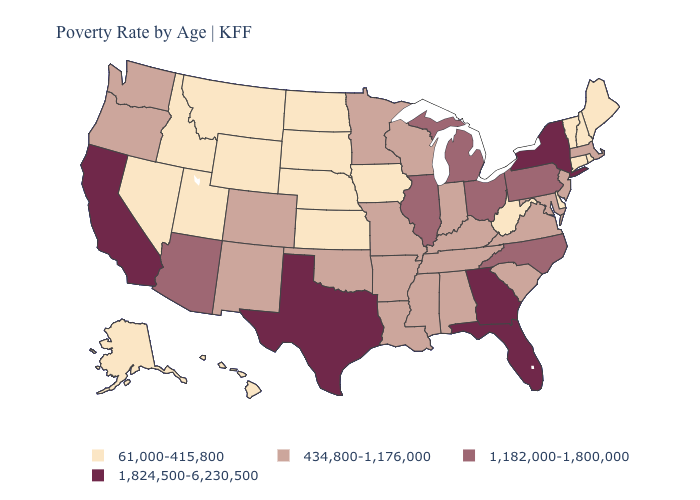How many symbols are there in the legend?
Answer briefly. 4. Which states have the lowest value in the USA?
Give a very brief answer. Alaska, Connecticut, Delaware, Hawaii, Idaho, Iowa, Kansas, Maine, Montana, Nebraska, Nevada, New Hampshire, North Dakota, Rhode Island, South Dakota, Utah, Vermont, West Virginia, Wyoming. Among the states that border Oklahoma , which have the lowest value?
Keep it brief. Kansas. What is the lowest value in the USA?
Concise answer only. 61,000-415,800. Does Michigan have the highest value in the MidWest?
Answer briefly. Yes. What is the highest value in the West ?
Give a very brief answer. 1,824,500-6,230,500. Which states hav the highest value in the South?
Short answer required. Florida, Georgia, Texas. Among the states that border Nevada , which have the lowest value?
Answer briefly. Idaho, Utah. Which states have the lowest value in the USA?
Answer briefly. Alaska, Connecticut, Delaware, Hawaii, Idaho, Iowa, Kansas, Maine, Montana, Nebraska, Nevada, New Hampshire, North Dakota, Rhode Island, South Dakota, Utah, Vermont, West Virginia, Wyoming. Does Tennessee have the lowest value in the South?
Write a very short answer. No. Which states hav the highest value in the South?
Quick response, please. Florida, Georgia, Texas. What is the lowest value in states that border Colorado?
Write a very short answer. 61,000-415,800. Name the states that have a value in the range 1,182,000-1,800,000?
Answer briefly. Arizona, Illinois, Michigan, North Carolina, Ohio, Pennsylvania. What is the value of New Jersey?
Write a very short answer. 434,800-1,176,000. Name the states that have a value in the range 61,000-415,800?
Keep it brief. Alaska, Connecticut, Delaware, Hawaii, Idaho, Iowa, Kansas, Maine, Montana, Nebraska, Nevada, New Hampshire, North Dakota, Rhode Island, South Dakota, Utah, Vermont, West Virginia, Wyoming. 